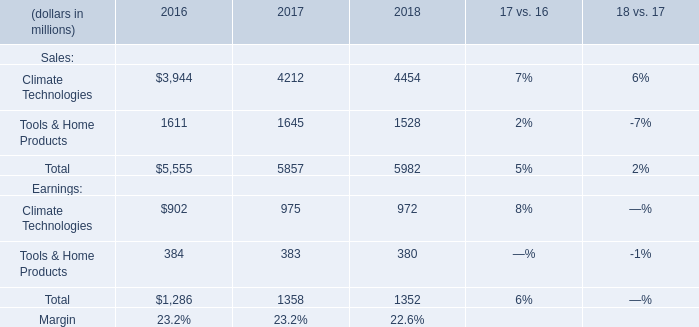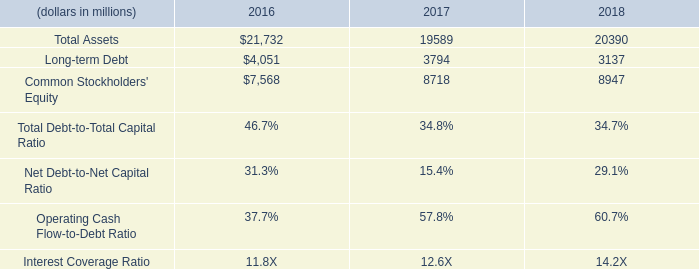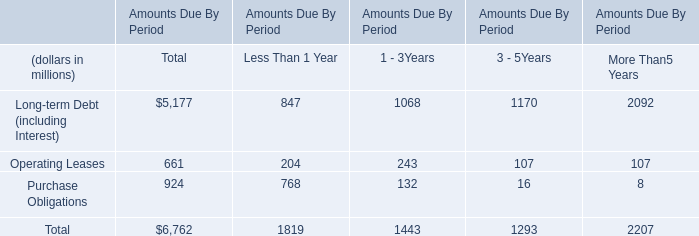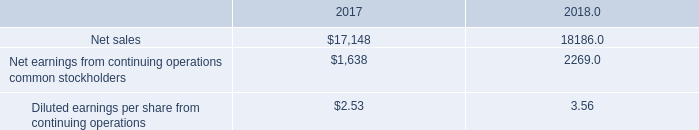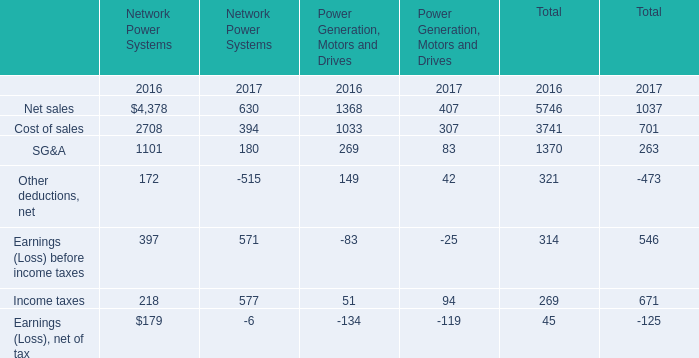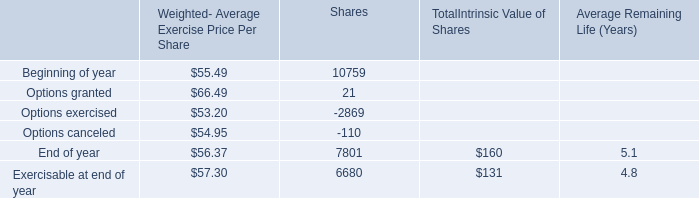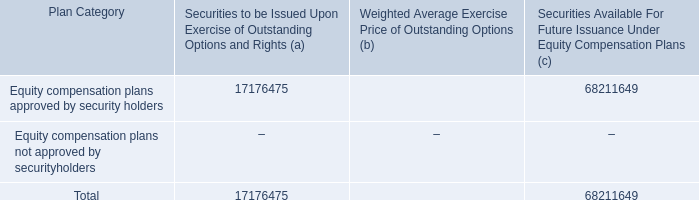what portion of the securities approved by security holders is to be issued upon exercise of outstanding options and rights? 
Computations: (17176475 / (17176475 + 68211649))
Answer: 0.20116. 